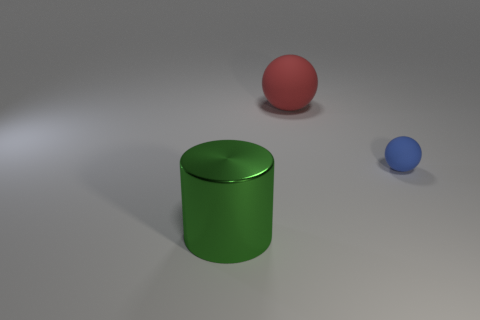Add 3 large shiny cylinders. How many objects exist? 6 Subtract all cylinders. How many objects are left? 2 Subtract all balls. Subtract all green shiny cylinders. How many objects are left? 0 Add 1 green objects. How many green objects are left? 2 Add 2 big green blocks. How many big green blocks exist? 2 Subtract 0 gray spheres. How many objects are left? 3 